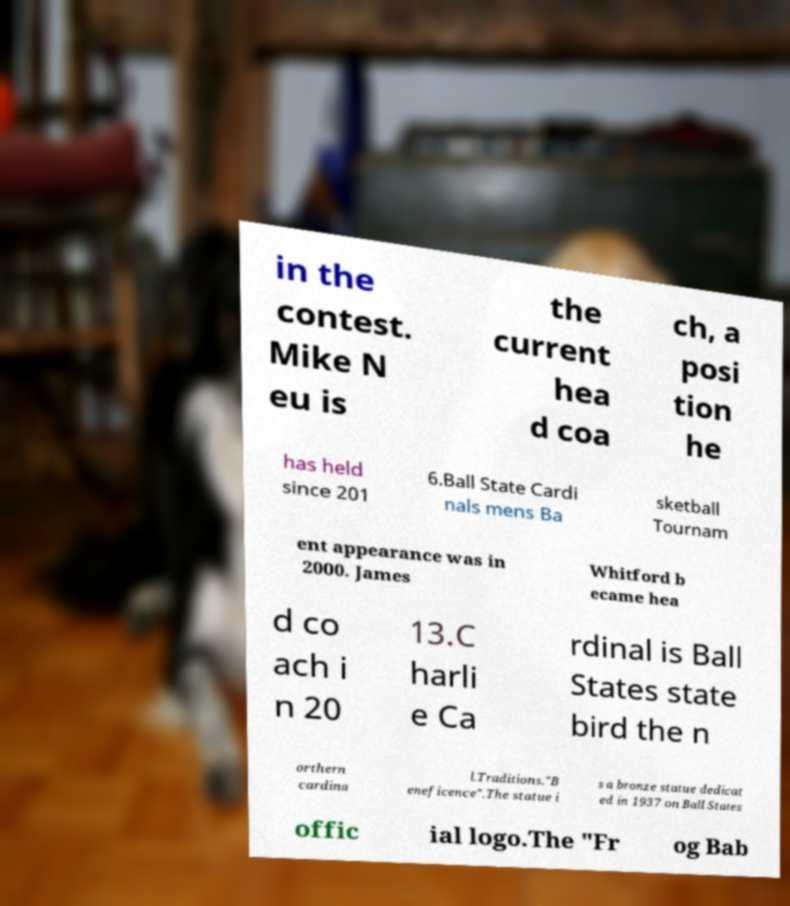What messages or text are displayed in this image? I need them in a readable, typed format. in the contest. Mike N eu is the current hea d coa ch, a posi tion he has held since 201 6.Ball State Cardi nals mens Ba sketball Tournam ent appearance was in 2000. James Whitford b ecame hea d co ach i n 20 13.C harli e Ca rdinal is Ball States state bird the n orthern cardina l.Traditions."B eneficence".The statue i s a bronze statue dedicat ed in 1937 on Ball States offic ial logo.The "Fr og Bab 